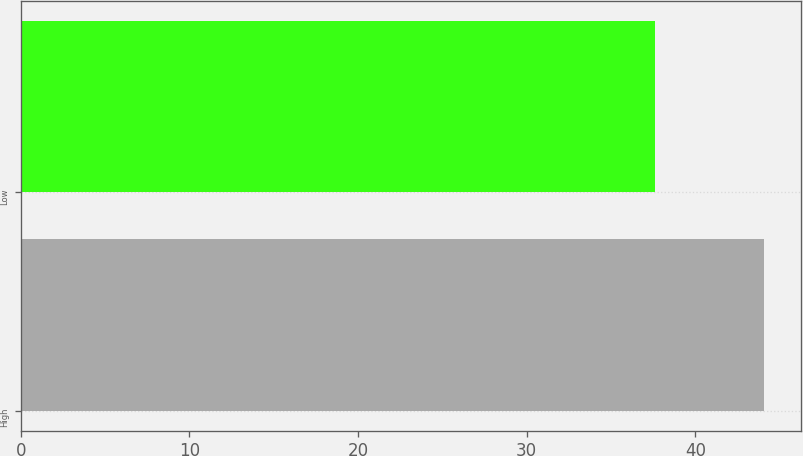Convert chart to OTSL. <chart><loc_0><loc_0><loc_500><loc_500><bar_chart><fcel>High<fcel>Low<nl><fcel>44.06<fcel>37.61<nl></chart> 